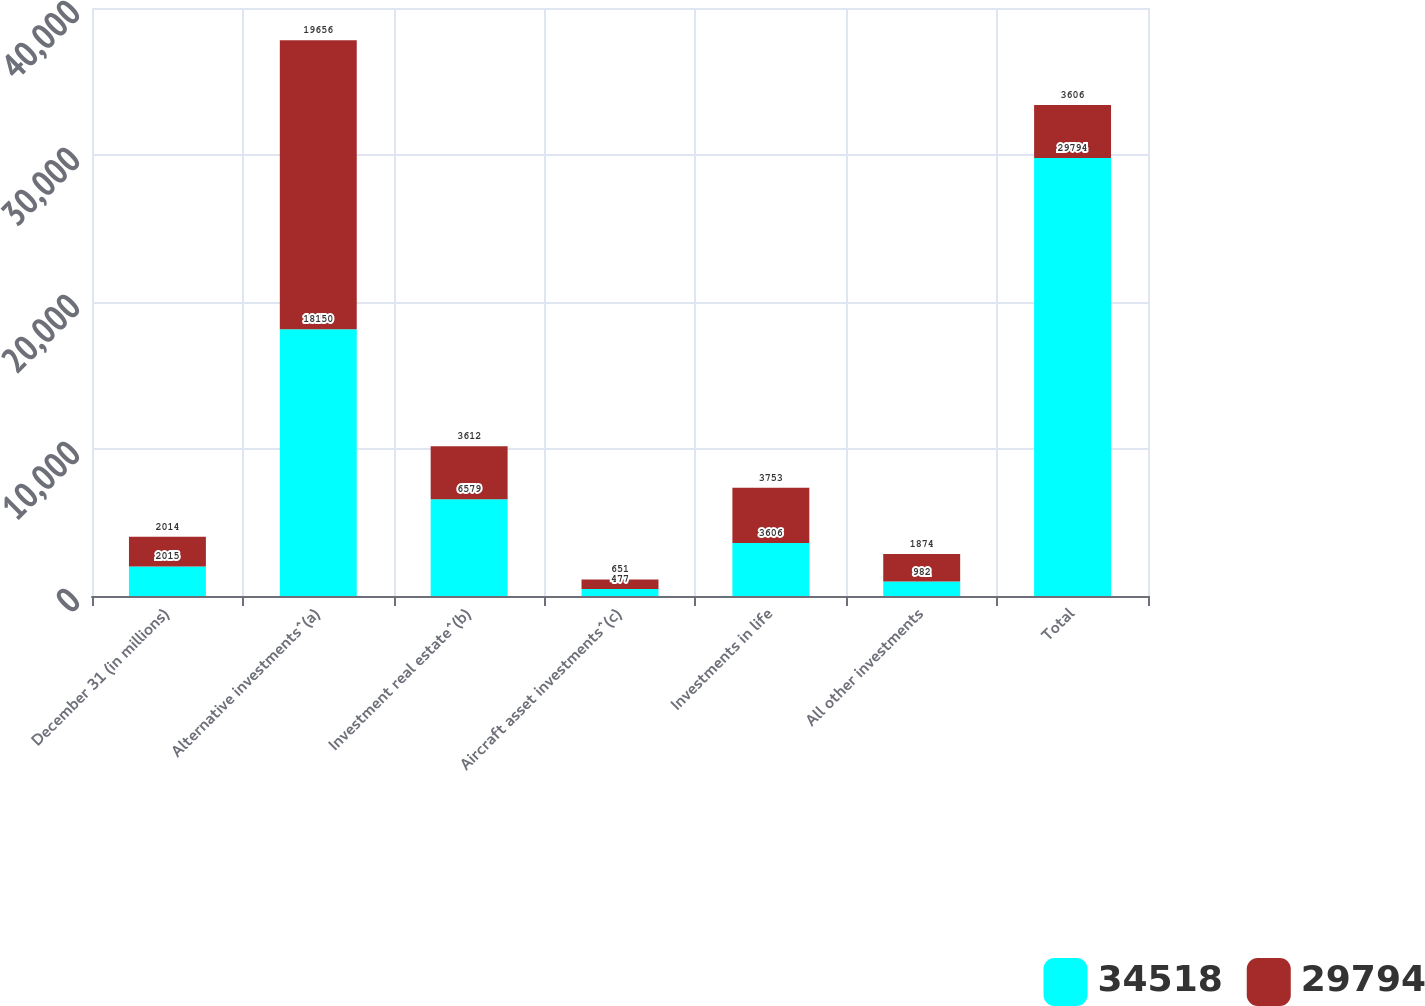<chart> <loc_0><loc_0><loc_500><loc_500><stacked_bar_chart><ecel><fcel>December 31 (in millions)<fcel>Alternative investments^(a)<fcel>Investment real estate^(b)<fcel>Aircraft asset investments^(c)<fcel>Investments in life<fcel>All other investments<fcel>Total<nl><fcel>34518<fcel>2015<fcel>18150<fcel>6579<fcel>477<fcel>3606<fcel>982<fcel>29794<nl><fcel>29794<fcel>2014<fcel>19656<fcel>3612<fcel>651<fcel>3753<fcel>1874<fcel>3606<nl></chart> 